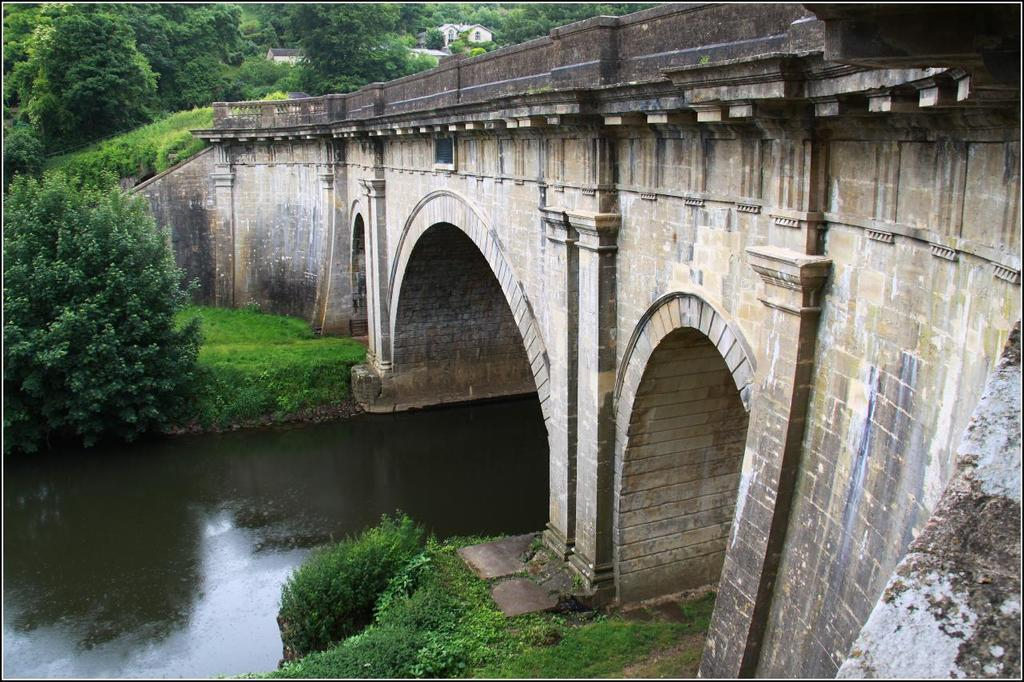What structure is located on the right side of the image? There is a bridge on the right side of the image. What can be seen under the bridge? Trees and water are visible under the bridge. What type of vegetation is at the top of the image? Trees are visible at the top of the image. How many pies are being baked on the bridge in the image? There are no pies present in the image, and the bridge is not being used for baking. 